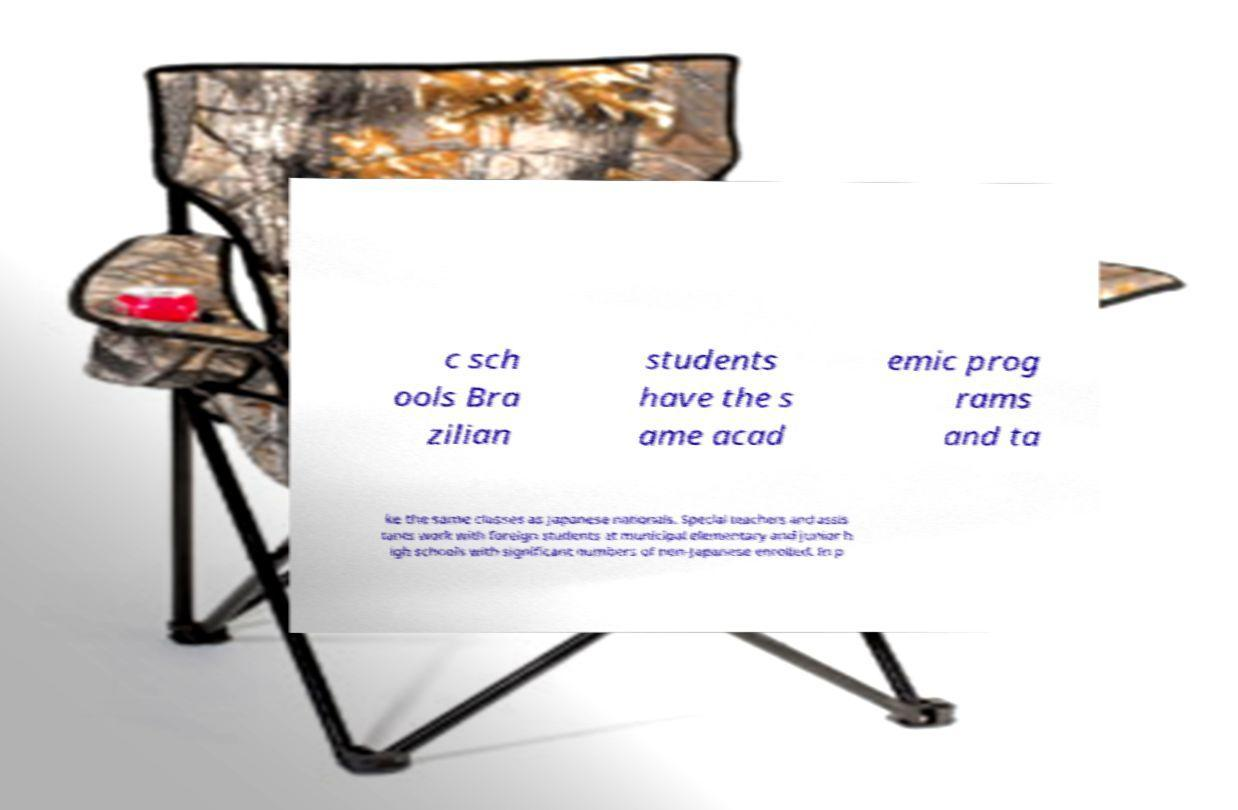For documentation purposes, I need the text within this image transcribed. Could you provide that? c sch ools Bra zilian students have the s ame acad emic prog rams and ta ke the same classes as Japanese nationals. Special teachers and assis tants work with foreign students at municipal elementary and junior h igh schools with significant numbers of non-Japanese enrolled. In p 